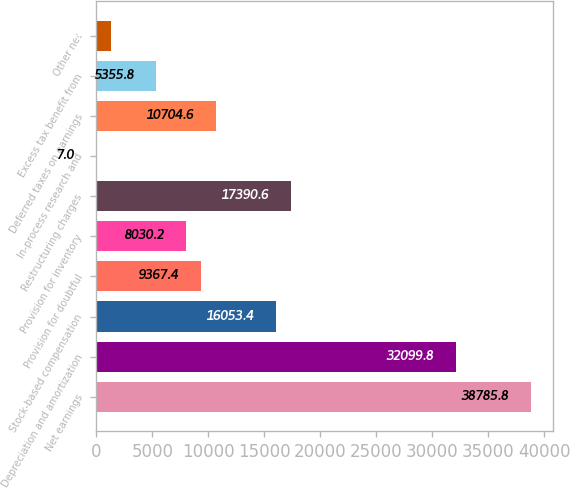<chart> <loc_0><loc_0><loc_500><loc_500><bar_chart><fcel>Net earnings<fcel>Depreciation and amortization<fcel>Stock-based compensation<fcel>Provision for doubtful<fcel>Provision for inventory<fcel>Restructuring charges<fcel>In-process research and<fcel>Deferred taxes on earnings<fcel>Excess tax benefit from<fcel>Other net<nl><fcel>38785.8<fcel>32099.8<fcel>16053.4<fcel>9367.4<fcel>8030.2<fcel>17390.6<fcel>7<fcel>10704.6<fcel>5355.8<fcel>1344.2<nl></chart> 